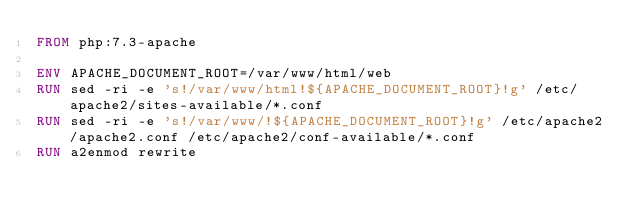Convert code to text. <code><loc_0><loc_0><loc_500><loc_500><_Dockerfile_>FROM php:7.3-apache

ENV APACHE_DOCUMENT_ROOT=/var/www/html/web
RUN sed -ri -e 's!/var/www/html!${APACHE_DOCUMENT_ROOT}!g' /etc/apache2/sites-available/*.conf
RUN sed -ri -e 's!/var/www/!${APACHE_DOCUMENT_ROOT}!g' /etc/apache2/apache2.conf /etc/apache2/conf-available/*.conf
RUN a2enmod rewrite

</code> 